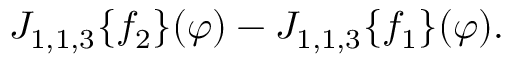<formula> <loc_0><loc_0><loc_500><loc_500>\begin{array} { r } { J _ { 1 , 1 , 3 } \{ f _ { 2 } \} ( \varphi ) - J _ { 1 , 1 , 3 } \{ f _ { 1 } \} ( \varphi ) . } \end{array}</formula> 